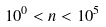<formula> <loc_0><loc_0><loc_500><loc_500>1 0 ^ { 0 } < n < 1 0 ^ { 5 }</formula> 